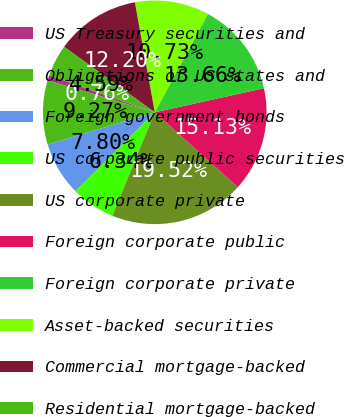Convert chart. <chart><loc_0><loc_0><loc_500><loc_500><pie_chart><fcel>US Treasury securities and<fcel>Obligations of US states and<fcel>Foreign government bonds<fcel>US corporate public securities<fcel>US corporate private<fcel>Foreign corporate public<fcel>Foreign corporate private<fcel>Asset-backed securities<fcel>Commercial mortgage-backed<fcel>Residential mortgage-backed<nl><fcel>0.76%<fcel>9.27%<fcel>7.8%<fcel>6.34%<fcel>19.52%<fcel>15.13%<fcel>13.66%<fcel>10.73%<fcel>12.2%<fcel>4.59%<nl></chart> 